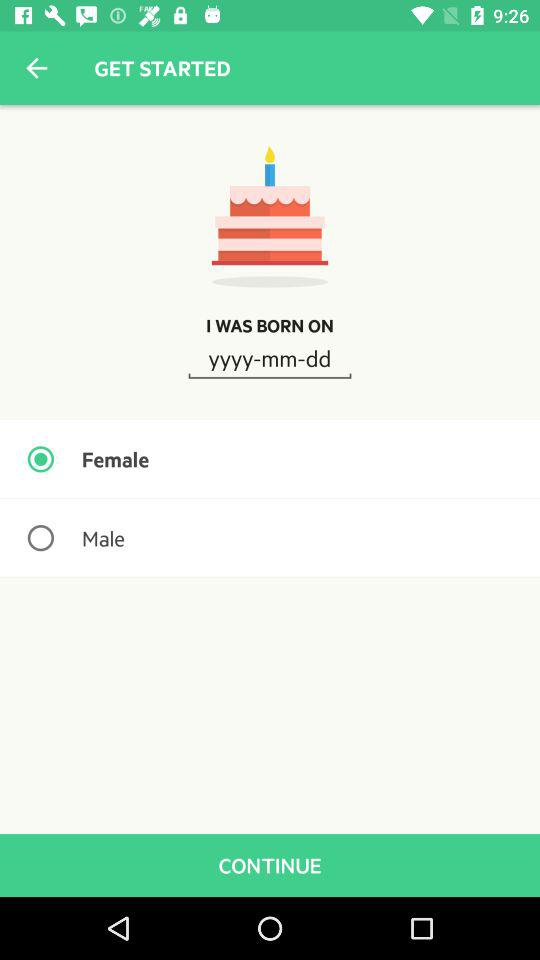What is the selected gender? The selected gender is female. 